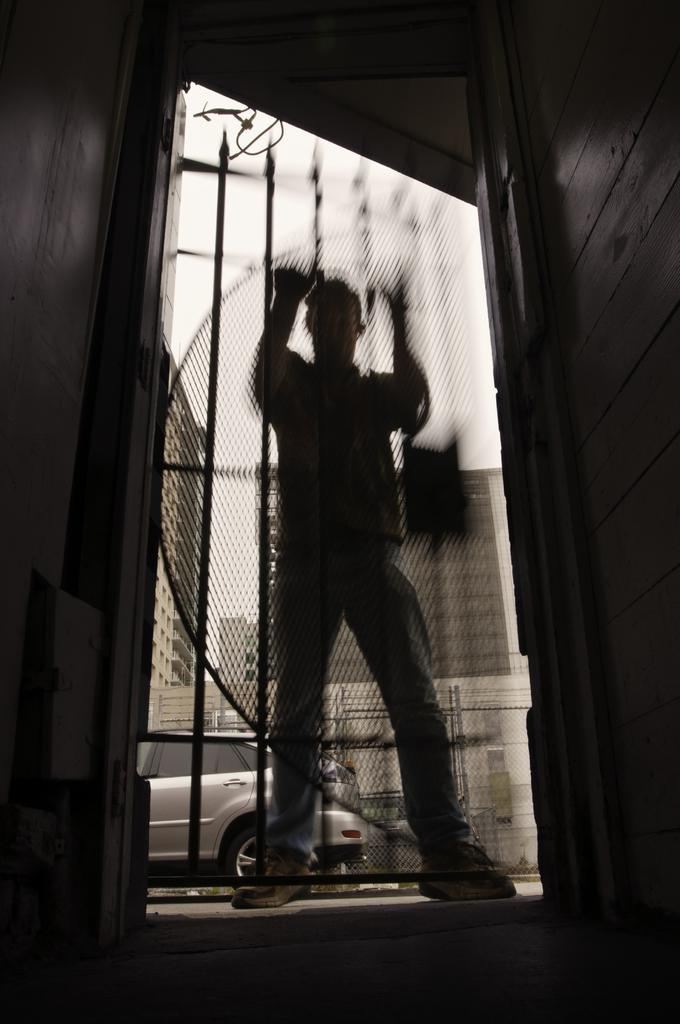Who is the main subject in the image? There is a man in the center of the image. What is the man standing in front of? The man is in front of a gate. What can be seen in the background of the image? There are buildings and a car in the background of the image. How many clocks are hanging on the gate in the image? There are no clocks visible on the gate in the image. What type of beef dish is being prepared in the background of the image? There is no beef dish or any food preparation visible in the image. 